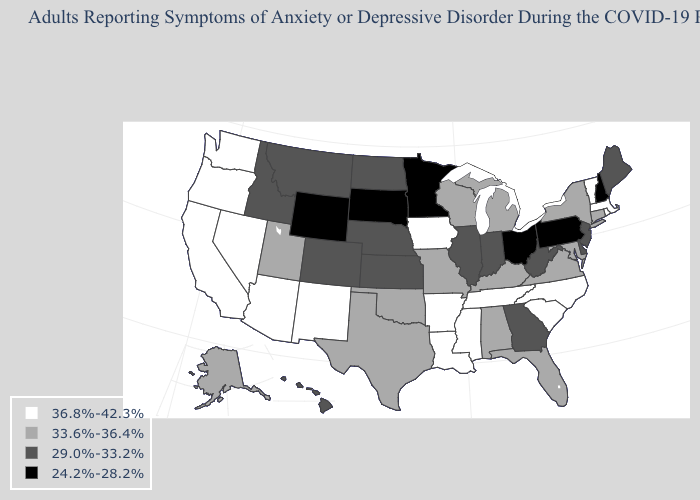Name the states that have a value in the range 29.0%-33.2%?
Concise answer only. Colorado, Delaware, Georgia, Hawaii, Idaho, Illinois, Indiana, Kansas, Maine, Montana, Nebraska, New Jersey, North Dakota, West Virginia. Name the states that have a value in the range 29.0%-33.2%?
Short answer required. Colorado, Delaware, Georgia, Hawaii, Idaho, Illinois, Indiana, Kansas, Maine, Montana, Nebraska, New Jersey, North Dakota, West Virginia. Name the states that have a value in the range 24.2%-28.2%?
Be succinct. Minnesota, New Hampshire, Ohio, Pennsylvania, South Dakota, Wyoming. Name the states that have a value in the range 29.0%-33.2%?
Short answer required. Colorado, Delaware, Georgia, Hawaii, Idaho, Illinois, Indiana, Kansas, Maine, Montana, Nebraska, New Jersey, North Dakota, West Virginia. Does Virginia have the same value as Hawaii?
Answer briefly. No. Which states have the lowest value in the Northeast?
Concise answer only. New Hampshire, Pennsylvania. What is the value of Illinois?
Be succinct. 29.0%-33.2%. Among the states that border Delaware , does Pennsylvania have the lowest value?
Keep it brief. Yes. Which states have the highest value in the USA?
Answer briefly. Arizona, Arkansas, California, Iowa, Louisiana, Massachusetts, Mississippi, Nevada, New Mexico, North Carolina, Oregon, Rhode Island, South Carolina, Tennessee, Vermont, Washington. Which states have the lowest value in the USA?
Short answer required. Minnesota, New Hampshire, Ohio, Pennsylvania, South Dakota, Wyoming. Among the states that border Wyoming , which have the highest value?
Short answer required. Utah. Is the legend a continuous bar?
Quick response, please. No. Which states hav the highest value in the South?
Give a very brief answer. Arkansas, Louisiana, Mississippi, North Carolina, South Carolina, Tennessee. Name the states that have a value in the range 36.8%-42.3%?
Write a very short answer. Arizona, Arkansas, California, Iowa, Louisiana, Massachusetts, Mississippi, Nevada, New Mexico, North Carolina, Oregon, Rhode Island, South Carolina, Tennessee, Vermont, Washington. Does Oklahoma have the highest value in the South?
Answer briefly. No. 